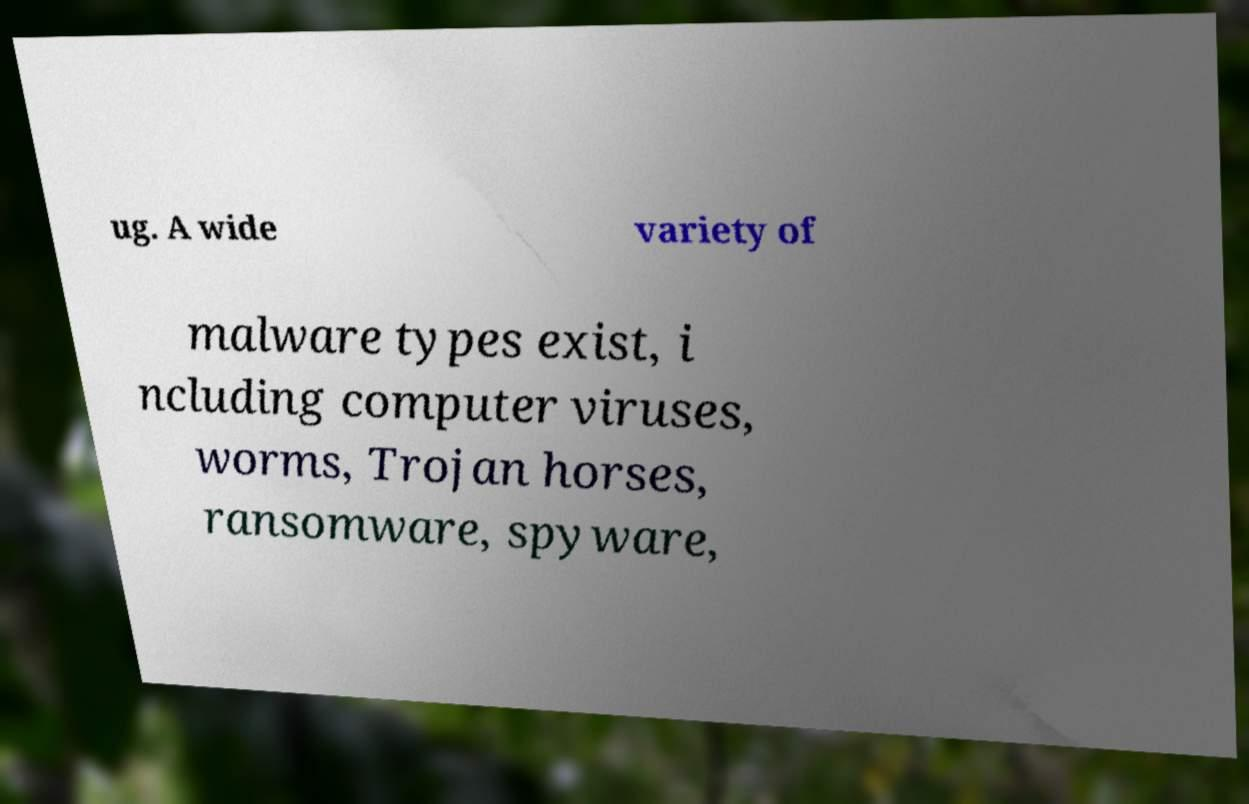There's text embedded in this image that I need extracted. Can you transcribe it verbatim? ug. A wide variety of malware types exist, i ncluding computer viruses, worms, Trojan horses, ransomware, spyware, 